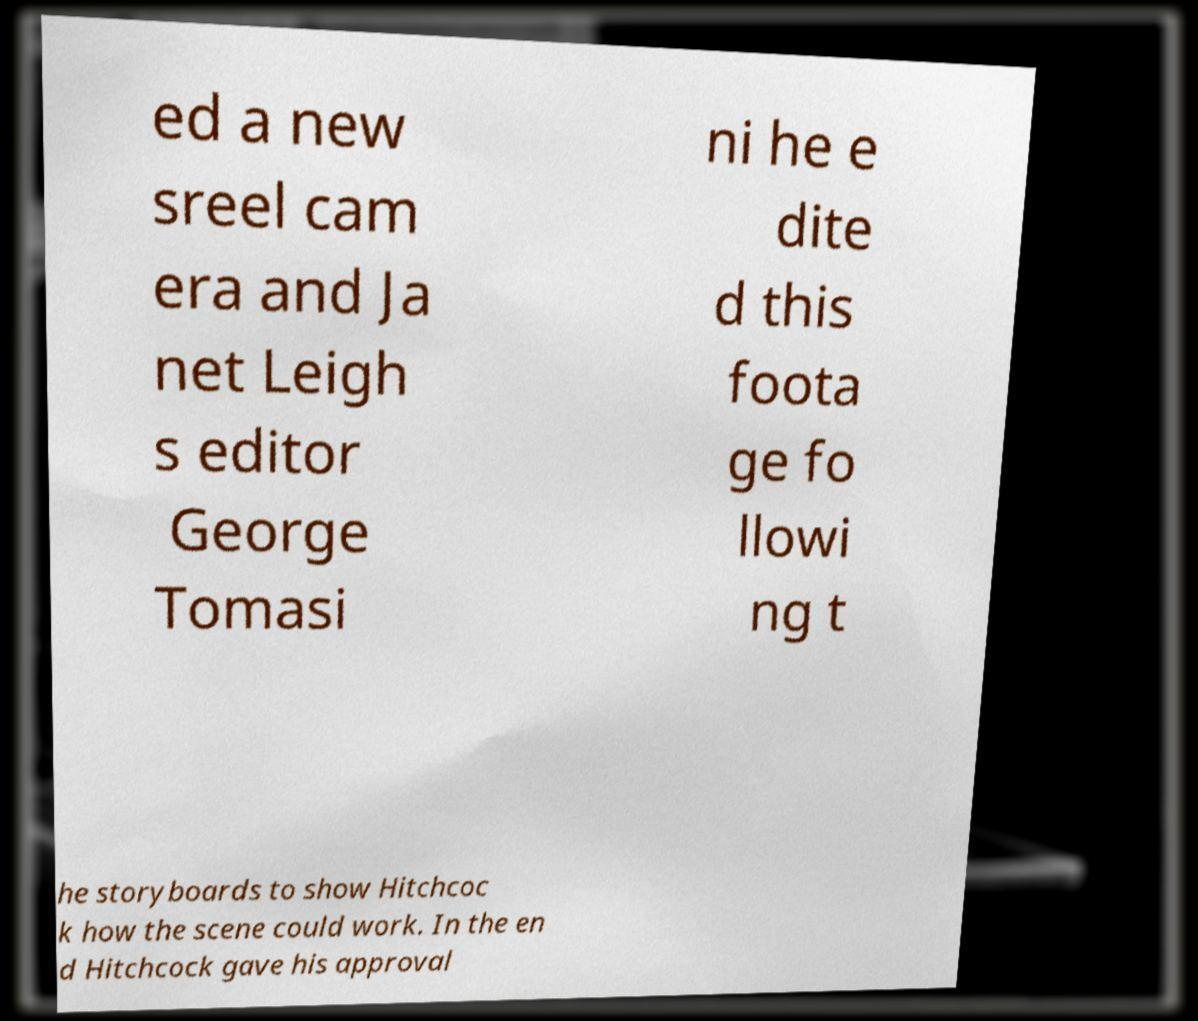Please read and relay the text visible in this image. What does it say? ed a new sreel cam era and Ja net Leigh s editor George Tomasi ni he e dite d this foota ge fo llowi ng t he storyboards to show Hitchcoc k how the scene could work. In the en d Hitchcock gave his approval 